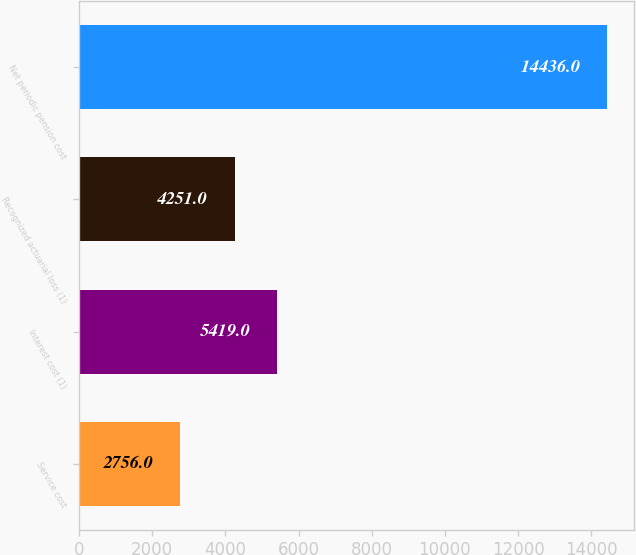<chart> <loc_0><loc_0><loc_500><loc_500><bar_chart><fcel>Service cost<fcel>Interest cost (1)<fcel>Recognized actuarial loss (1)<fcel>Net periodic pension cost<nl><fcel>2756<fcel>5419<fcel>4251<fcel>14436<nl></chart> 